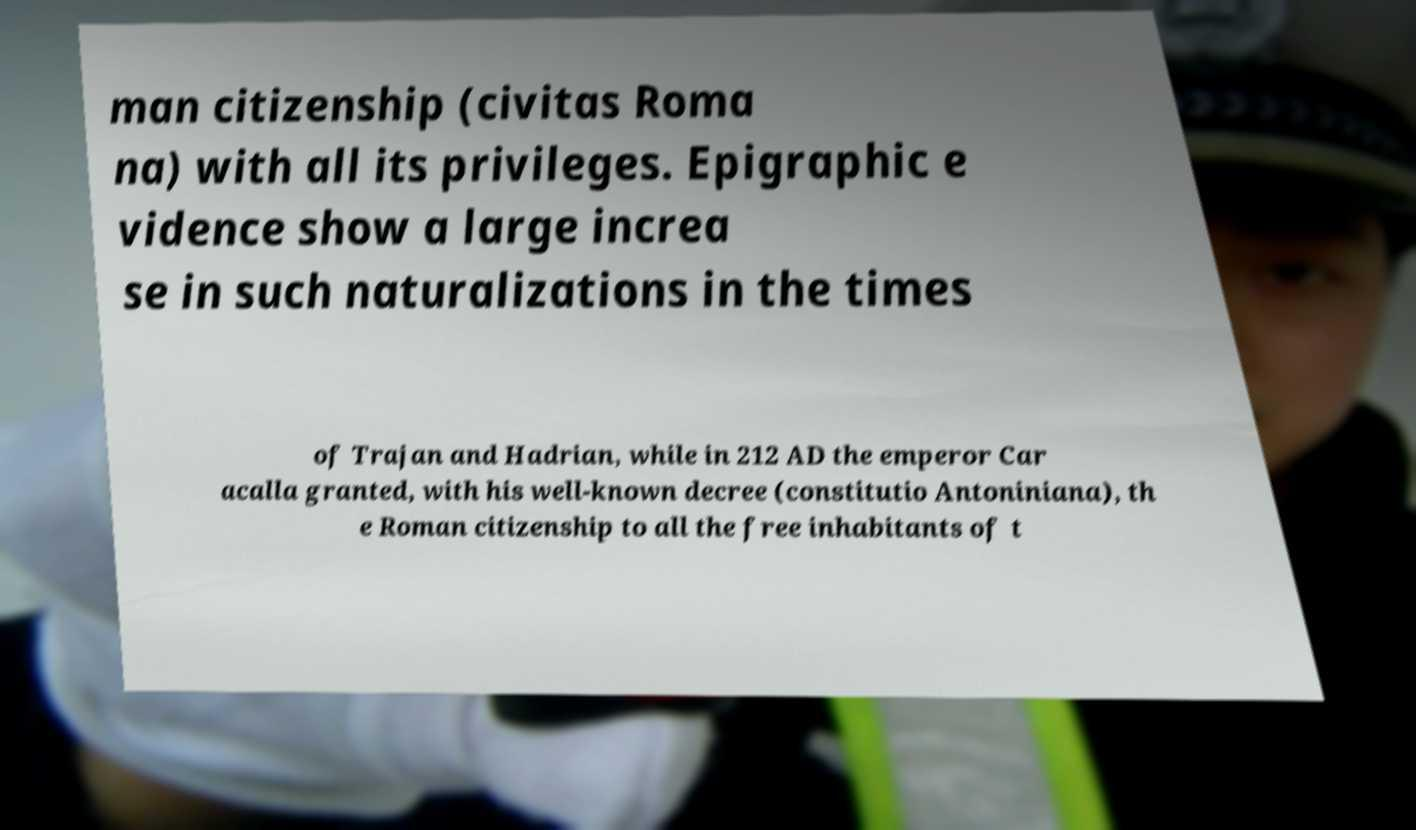Can you read and provide the text displayed in the image?This photo seems to have some interesting text. Can you extract and type it out for me? man citizenship (civitas Roma na) with all its privileges. Epigraphic e vidence show a large increa se in such naturalizations in the times of Trajan and Hadrian, while in 212 AD the emperor Car acalla granted, with his well-known decree (constitutio Antoniniana), th e Roman citizenship to all the free inhabitants of t 